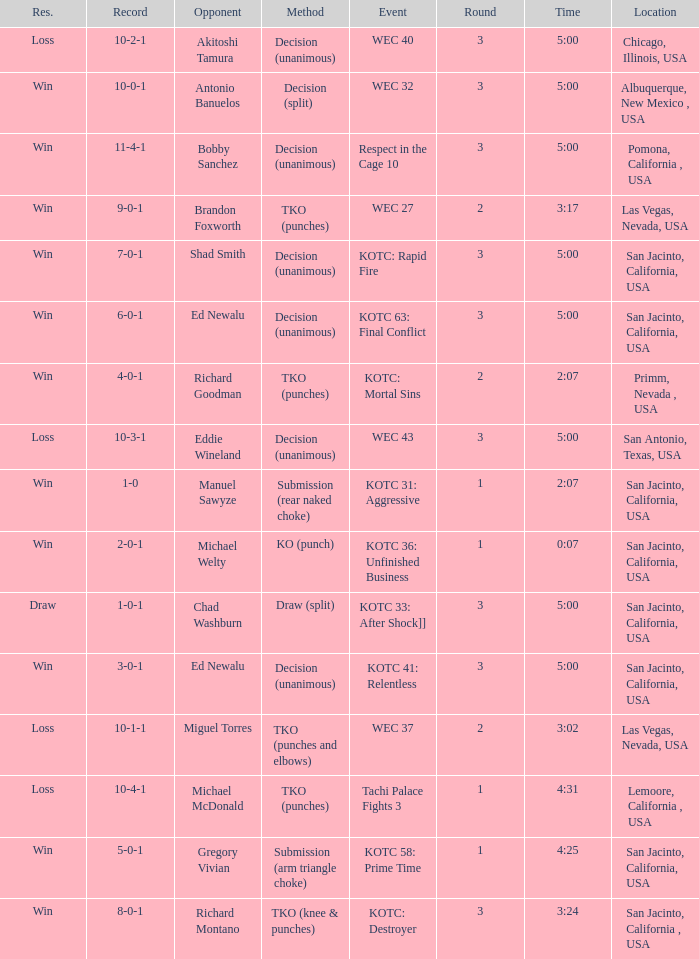What location did the event kotc: mortal sins take place? Primm, Nevada , USA. 